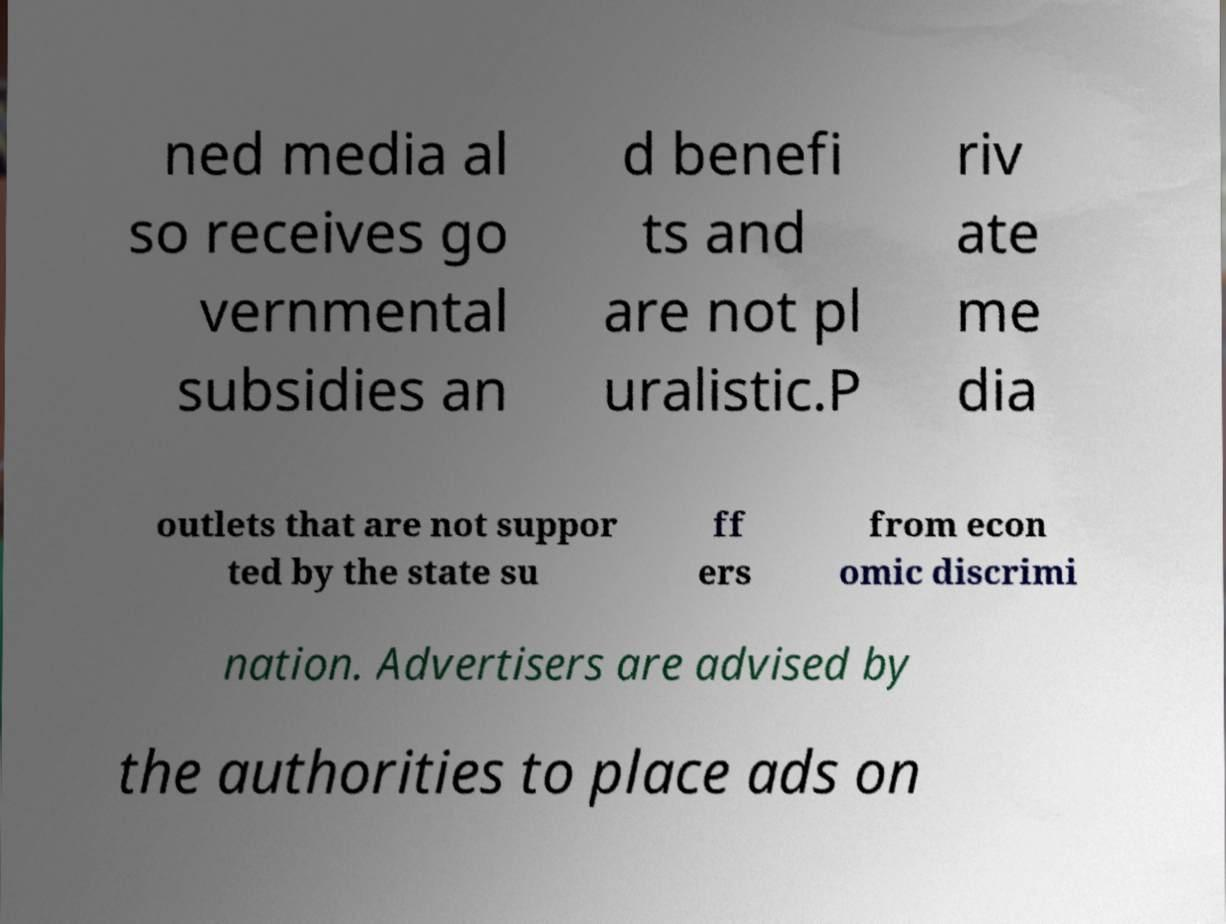Could you assist in decoding the text presented in this image and type it out clearly? ned media al so receives go vernmental subsidies an d benefi ts and are not pl uralistic.P riv ate me dia outlets that are not suppor ted by the state su ff ers from econ omic discrimi nation. Advertisers are advised by the authorities to place ads on 